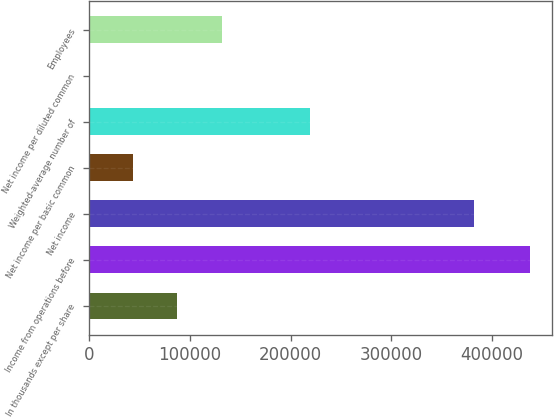Convert chart. <chart><loc_0><loc_0><loc_500><loc_500><bar_chart><fcel>In thousands except per share<fcel>Income from operations before<fcel>Net income<fcel>Net income per basic common<fcel>Weighted-average number of<fcel>Net income per diluted common<fcel>Employees<nl><fcel>87575.8<fcel>437863<fcel>381763<fcel>43789.9<fcel>218934<fcel>4.06<fcel>131362<nl></chart> 